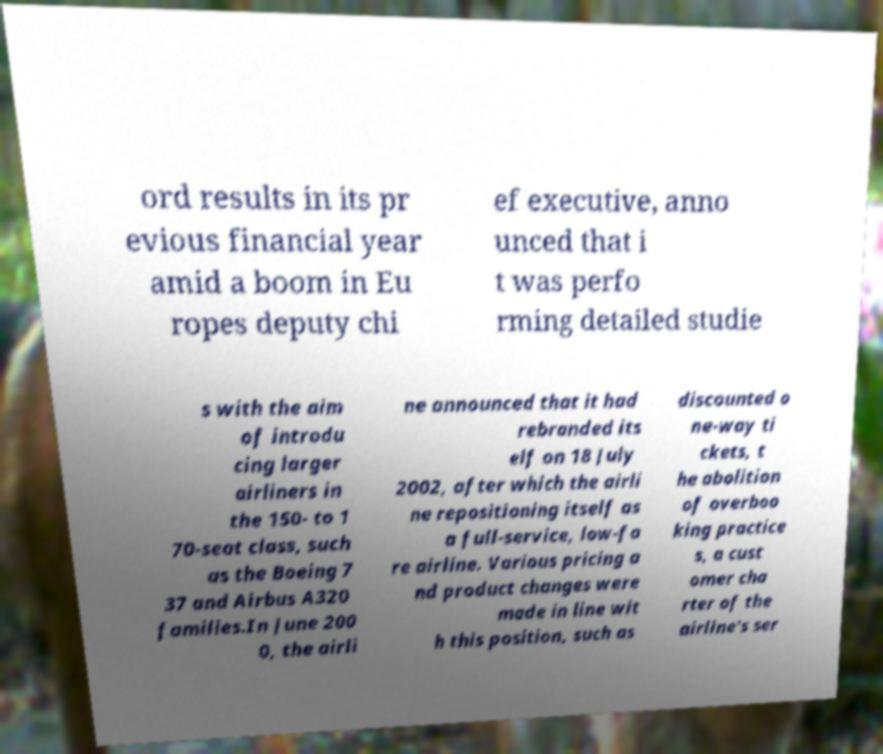Can you accurately transcribe the text from the provided image for me? ord results in its pr evious financial year amid a boom in Eu ropes deputy chi ef executive, anno unced that i t was perfo rming detailed studie s with the aim of introdu cing larger airliners in the 150- to 1 70-seat class, such as the Boeing 7 37 and Airbus A320 families.In June 200 0, the airli ne announced that it had rebranded its elf on 18 July 2002, after which the airli ne repositioning itself as a full-service, low-fa re airline. Various pricing a nd product changes were made in line wit h this position, such as discounted o ne-way ti ckets, t he abolition of overboo king practice s, a cust omer cha rter of the airline's ser 